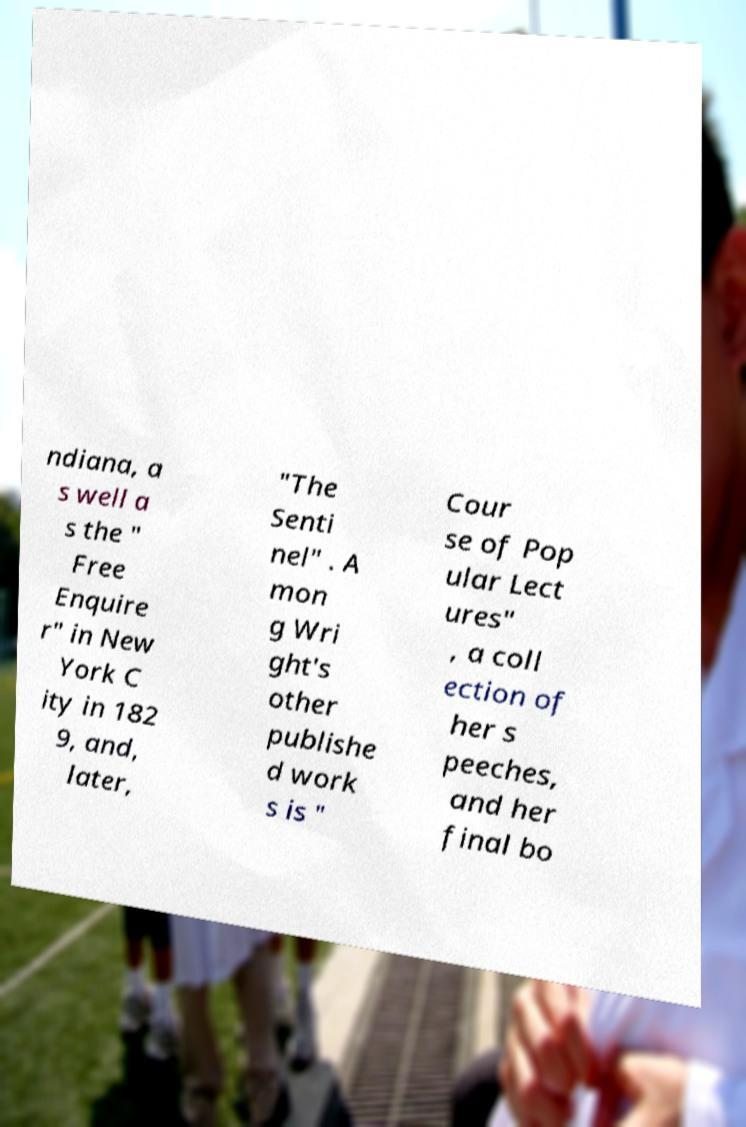Could you assist in decoding the text presented in this image and type it out clearly? ndiana, a s well a s the " Free Enquire r" in New York C ity in 182 9, and, later, "The Senti nel" . A mon g Wri ght's other publishe d work s is " Cour se of Pop ular Lect ures" , a coll ection of her s peeches, and her final bo 